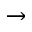<formula> <loc_0><loc_0><loc_500><loc_500>\rightarrow</formula> 